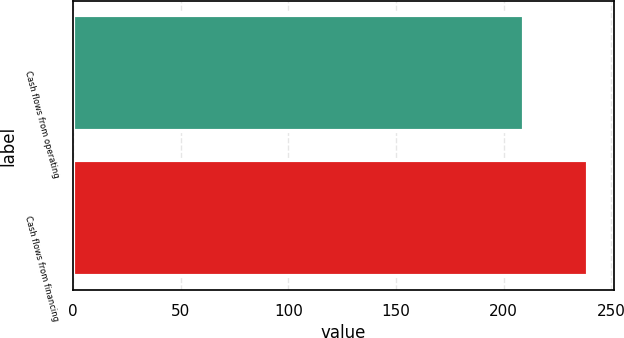<chart> <loc_0><loc_0><loc_500><loc_500><bar_chart><fcel>Cash flows from operating<fcel>Cash flows from financing<nl><fcel>209.3<fcel>239.3<nl></chart> 